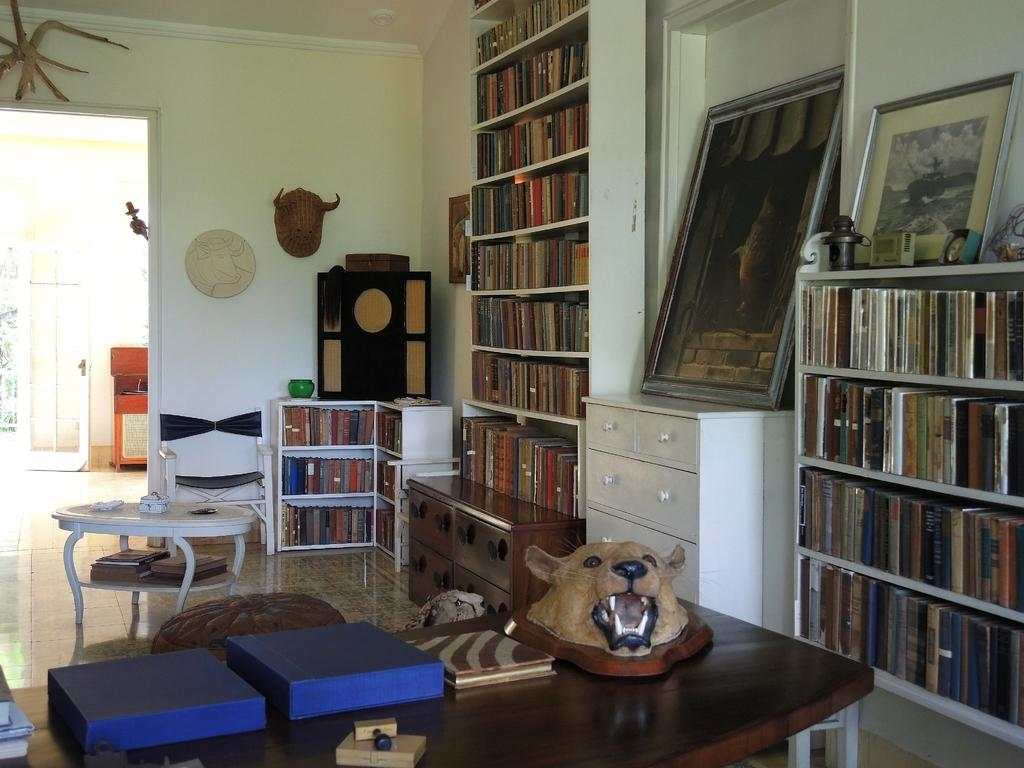What type of furniture is present in the room? There is a table in the room. What other object is present for storage or display? There is a book rack in the room. What type of decorative item can be seen in the room? There is a frame in the room. What item is placed on the table? There is a book on the table. How many pies are stored in the crate in the room? There is no crate or pies mentioned in the provided facts, so we cannot answer this question. 